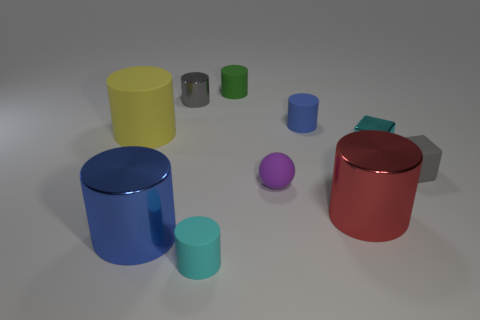There is a matte object that is the same color as the tiny metallic cube; what is its shape?
Keep it short and to the point. Cylinder. How many red metal spheres have the same size as the matte sphere?
Your answer should be compact. 0. What number of objects are either matte cylinders that are to the right of the tiny ball or tiny cyan objects that are to the right of the large red metal thing?
Offer a very short reply. 2. Do the tiny cube behind the small rubber block and the large cylinder that is to the right of the blue metallic cylinder have the same material?
Provide a succinct answer. Yes. What shape is the tiny purple rubber object that is in front of the tiny cube that is in front of the tiny cyan block?
Give a very brief answer. Sphere. Are there any other things that are the same color as the tiny shiny block?
Offer a very short reply. Yes. There is a tiny cyan thing to the right of the tiny matte cylinder that is behind the small gray cylinder; are there any objects to the left of it?
Keep it short and to the point. Yes. Do the small rubber cylinder in front of the large blue metallic cylinder and the small metal object in front of the tiny shiny cylinder have the same color?
Make the answer very short. Yes. There is a red cylinder that is the same size as the yellow cylinder; what material is it?
Give a very brief answer. Metal. What size is the blue object that is to the left of the green matte object that is behind the gray thing behind the small gray matte thing?
Your answer should be compact. Large. 